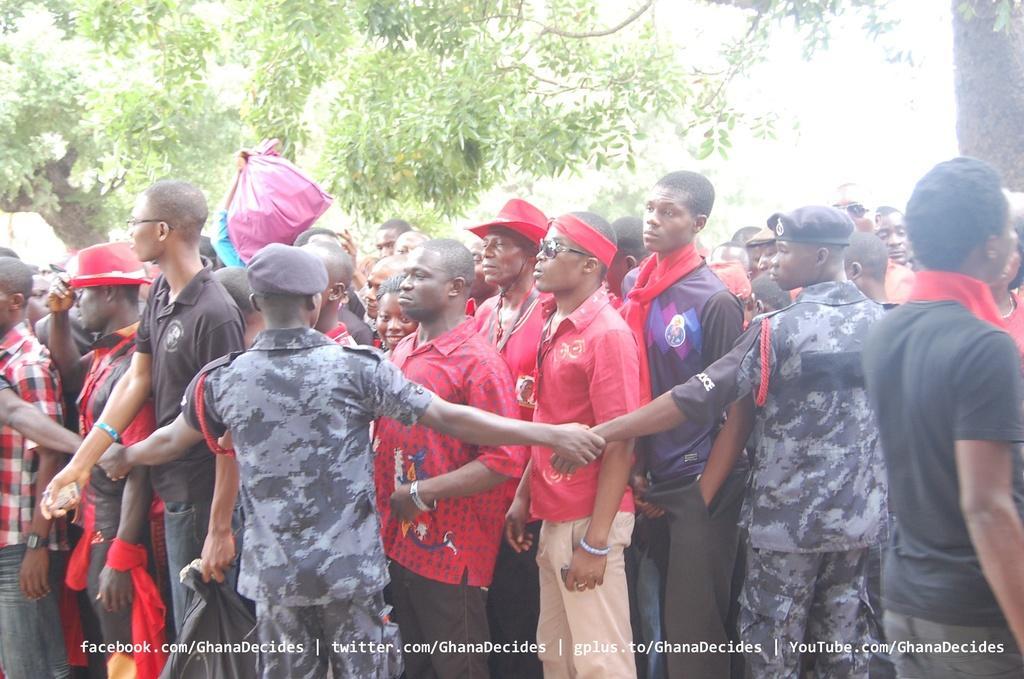Can you describe this image briefly? There is a crowd. Few people are wearing caps and hat. In the back there are trees. At the bottom there is something written. Also there is a person holding a packet. 